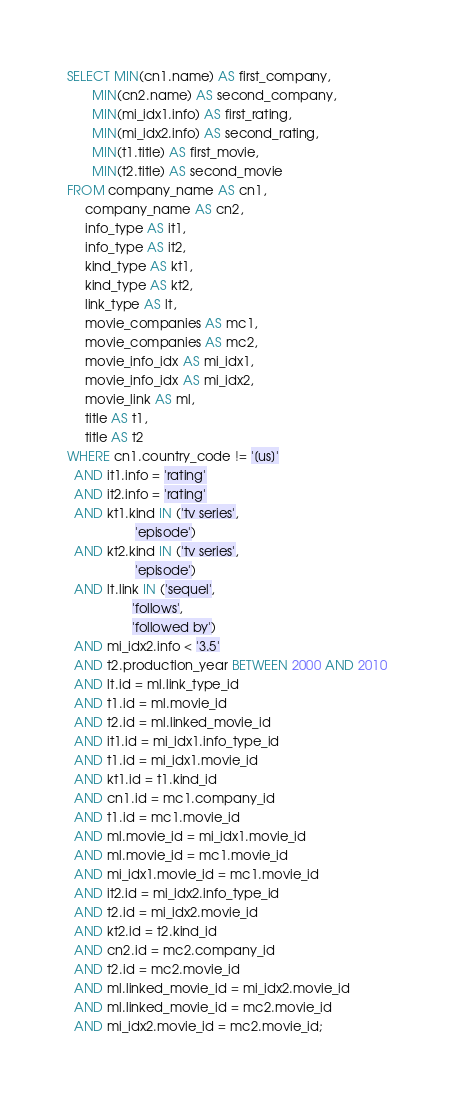Convert code to text. <code><loc_0><loc_0><loc_500><loc_500><_SQL_>SELECT MIN(cn1.name) AS first_company,
       MIN(cn2.name) AS second_company,
       MIN(mi_idx1.info) AS first_rating,
       MIN(mi_idx2.info) AS second_rating,
       MIN(t1.title) AS first_movie,
       MIN(t2.title) AS second_movie
FROM company_name AS cn1,
     company_name AS cn2,
     info_type AS it1,
     info_type AS it2,
     kind_type AS kt1,
     kind_type AS kt2,
     link_type AS lt,
     movie_companies AS mc1,
     movie_companies AS mc2,
     movie_info_idx AS mi_idx1,
     movie_info_idx AS mi_idx2,
     movie_link AS ml,
     title AS t1,
     title AS t2
WHERE cn1.country_code != '[us]'
  AND it1.info = 'rating'
  AND it2.info = 'rating'
  AND kt1.kind IN ('tv series',
                   'episode')
  AND kt2.kind IN ('tv series',
                   'episode')
  AND lt.link IN ('sequel',
                  'follows',
                  'followed by')
  AND mi_idx2.info < '3.5'
  AND t2.production_year BETWEEN 2000 AND 2010
  AND lt.id = ml.link_type_id
  AND t1.id = ml.movie_id
  AND t2.id = ml.linked_movie_id
  AND it1.id = mi_idx1.info_type_id
  AND t1.id = mi_idx1.movie_id
  AND kt1.id = t1.kind_id
  AND cn1.id = mc1.company_id
  AND t1.id = mc1.movie_id
  AND ml.movie_id = mi_idx1.movie_id
  AND ml.movie_id = mc1.movie_id
  AND mi_idx1.movie_id = mc1.movie_id
  AND it2.id = mi_idx2.info_type_id
  AND t2.id = mi_idx2.movie_id
  AND kt2.id = t2.kind_id
  AND cn2.id = mc2.company_id
  AND t2.id = mc2.movie_id
  AND ml.linked_movie_id = mi_idx2.movie_id
  AND ml.linked_movie_id = mc2.movie_id
  AND mi_idx2.movie_id = mc2.movie_id;

</code> 